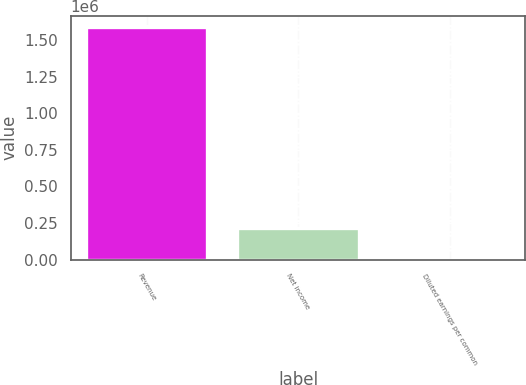Convert chart to OTSL. <chart><loc_0><loc_0><loc_500><loc_500><bar_chart><fcel>Revenue<fcel>Net income<fcel>Diluted earnings per common<nl><fcel>1.58502e+06<fcel>218364<fcel>1.14<nl></chart> 